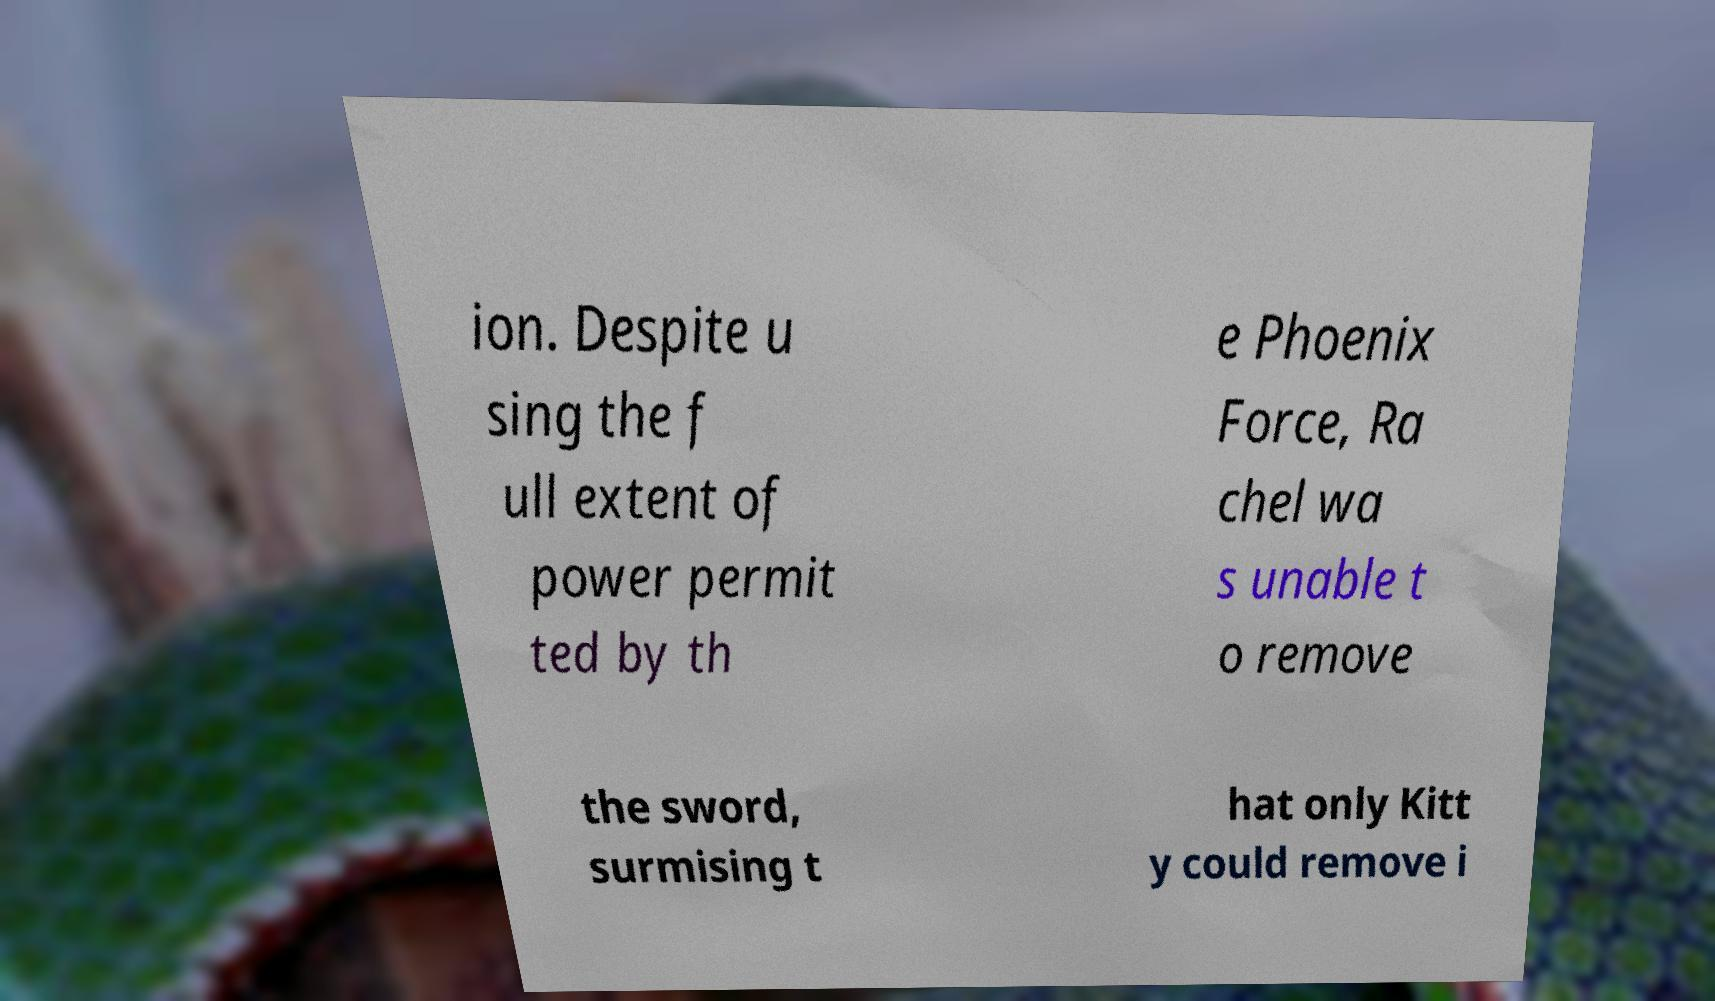Could you extract and type out the text from this image? ion. Despite u sing the f ull extent of power permit ted by th e Phoenix Force, Ra chel wa s unable t o remove the sword, surmising t hat only Kitt y could remove i 